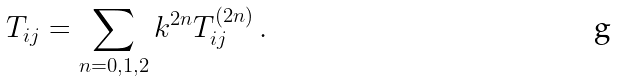<formula> <loc_0><loc_0><loc_500><loc_500>T _ { i j } = \sum _ { n = 0 , 1 , 2 } k ^ { 2 n } T _ { i j } ^ { ( 2 n ) } \, .</formula> 